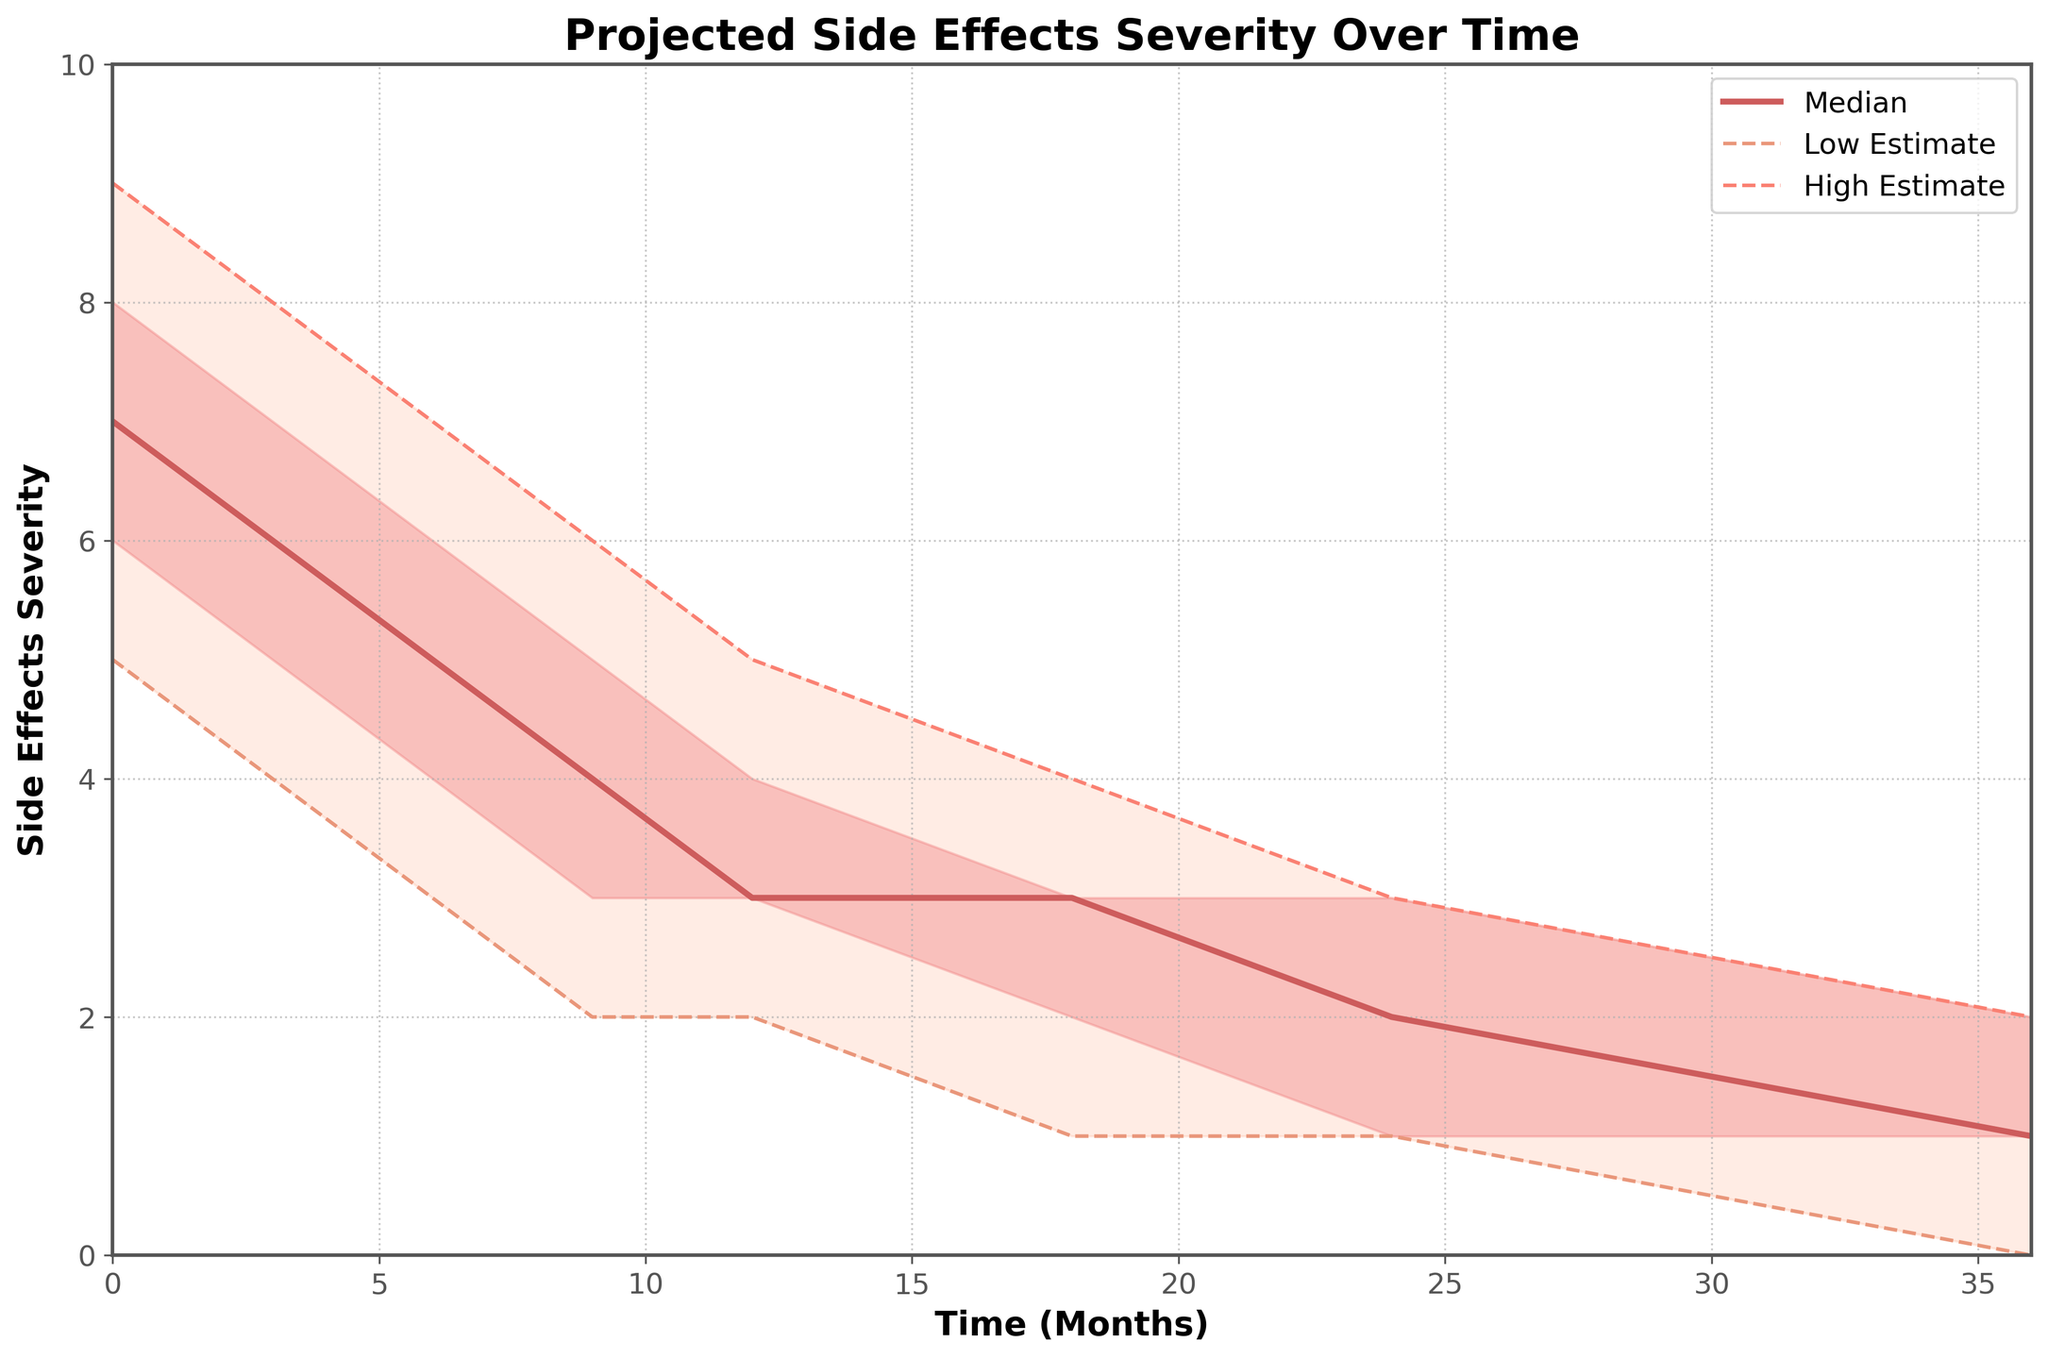What is the title of the figure? The title of the figure is usually displayed prominently at the top and should describe the contents clearly. In this case, the title explicitly states that the figure represents “Projected Side Effects Severity Over Time.”
Answer: Projected Side Effects Severity Over Time How many months does the figure cover? To find this information, look at the x-axis labeled "Time (Months)". The x-axis ranges from 0 to 36 months.
Answer: 36 months What is the median severity at 12 months? Examine the "Median" line in the chart at the 12-month mark. According to the data, the value is 3.
Answer: 3 Which estimate shows the lowest severity at 24 months? Check the values for all estimates at the 24-month mark. These include Low Estimate, Lower Quartile, Median, Upper Quartile, and High Estimate. The lowest value is for the Low Estimate, which is 1.
Answer: Low Estimate How does the median severity change from 0 to 6 months? To find how the median changes over time, look at the "Median" line. At 0 months, the median is 7, and at 6 months, it is 5. The change is 7 - 5 = 2 units decrease.
Answer: Decreases by 2 units What is the estimated range of side effect severity at 9 months? Look at the Low Estimate and High Estimate values at 9 months. The Low Estimate is 2, and the High Estimate is 6, so the range is 6 - 2 = 4 units.
Answer: 4 units Which period shows the sharpest decline in the median side effect severity? Examine the slope of the median line. The sharpest decline can be visually identified between 0 and 3 months, where the median drops from 7 to 6, indicating a decline of 1 unit.
Answer: 0 to 3 months Compare the side effect severity at 36 months for the Lower Quartile and Upper Quartile. Which one is higher? Refer to the Lower Quartile and Upper Quartile lines at 36 months. The Lower Quartile is 1, and the Upper Quartile is 2.
Answer: Upper Quartile At what point do the Low Estimate and Lower Quartile values become almost identical? Look for where the Low Estimate and Lower Quartile values converge. This occurs around 24 months, where both estimates are approximately 1.
Answer: 24 months In terms of pattern, how does the High Estimate line behave over the entire period? Observe the High Estimate line's general trend. It starts at 9 and consistently decreases to 2 over the 36 months.
Answer: Consistently decreases 